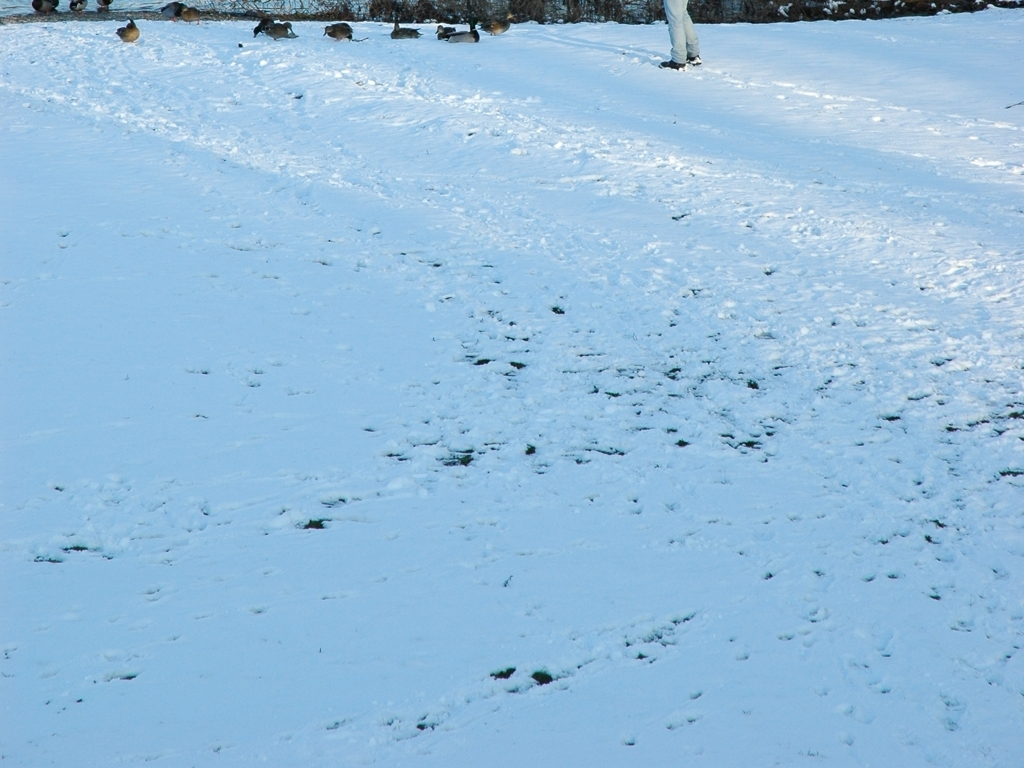Are there any indications of recent activity in this snow-covered landscape? Yes, there are footprints and tracks crisscrossing the snow, indicative of recent activity by people and possibly animals in the area. 